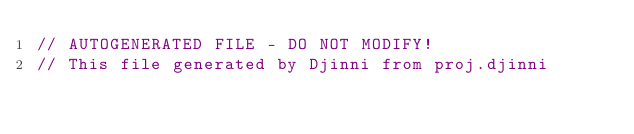<code> <loc_0><loc_0><loc_500><loc_500><_ObjectiveC_>// AUTOGENERATED FILE - DO NOT MODIFY!
// This file generated by Djinni from proj.djinni
</code> 